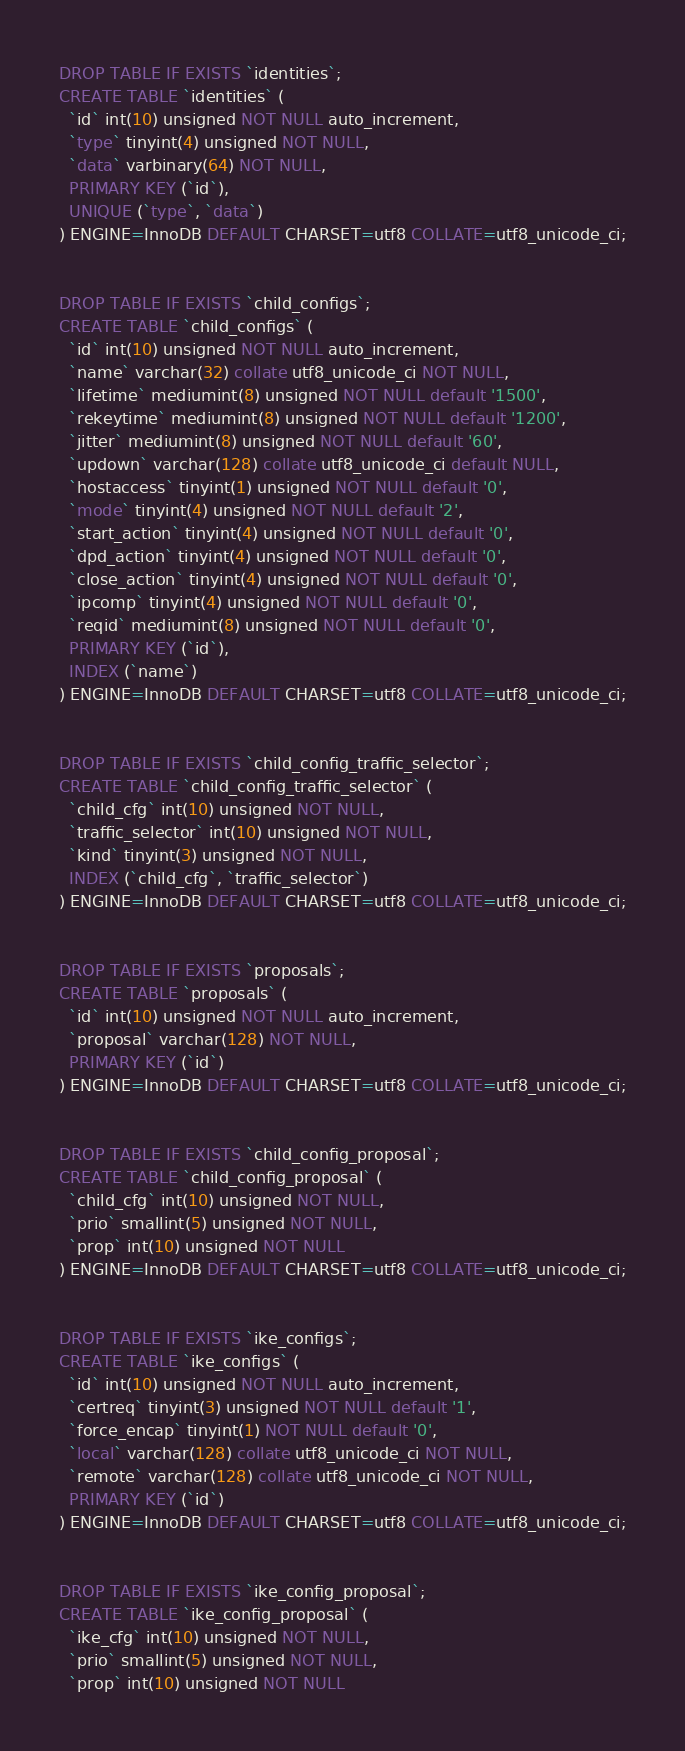<code> <loc_0><loc_0><loc_500><loc_500><_SQL_>
DROP TABLE IF EXISTS `identities`;
CREATE TABLE `identities` (
  `id` int(10) unsigned NOT NULL auto_increment,
  `type` tinyint(4) unsigned NOT NULL,
  `data` varbinary(64) NOT NULL,
  PRIMARY KEY (`id`),
  UNIQUE (`type`, `data`)
) ENGINE=InnoDB DEFAULT CHARSET=utf8 COLLATE=utf8_unicode_ci;


DROP TABLE IF EXISTS `child_configs`;
CREATE TABLE `child_configs` (
  `id` int(10) unsigned NOT NULL auto_increment,
  `name` varchar(32) collate utf8_unicode_ci NOT NULL,
  `lifetime` mediumint(8) unsigned NOT NULL default '1500',
  `rekeytime` mediumint(8) unsigned NOT NULL default '1200',
  `jitter` mediumint(8) unsigned NOT NULL default '60',
  `updown` varchar(128) collate utf8_unicode_ci default NULL,
  `hostaccess` tinyint(1) unsigned NOT NULL default '0',
  `mode` tinyint(4) unsigned NOT NULL default '2',
  `start_action` tinyint(4) unsigned NOT NULL default '0',
  `dpd_action` tinyint(4) unsigned NOT NULL default '0',
  `close_action` tinyint(4) unsigned NOT NULL default '0',
  `ipcomp` tinyint(4) unsigned NOT NULL default '0',
  `reqid` mediumint(8) unsigned NOT NULL default '0',
  PRIMARY KEY (`id`),
  INDEX (`name`)
) ENGINE=InnoDB DEFAULT CHARSET=utf8 COLLATE=utf8_unicode_ci;


DROP TABLE IF EXISTS `child_config_traffic_selector`;
CREATE TABLE `child_config_traffic_selector` (
  `child_cfg` int(10) unsigned NOT NULL,
  `traffic_selector` int(10) unsigned NOT NULL,
  `kind` tinyint(3) unsigned NOT NULL,
  INDEX (`child_cfg`, `traffic_selector`)
) ENGINE=InnoDB DEFAULT CHARSET=utf8 COLLATE=utf8_unicode_ci;


DROP TABLE IF EXISTS `proposals`;
CREATE TABLE `proposals` (
  `id` int(10) unsigned NOT NULL auto_increment,
  `proposal` varchar(128) NOT NULL,
  PRIMARY KEY (`id`)
) ENGINE=InnoDB DEFAULT CHARSET=utf8 COLLATE=utf8_unicode_ci;


DROP TABLE IF EXISTS `child_config_proposal`;
CREATE TABLE `child_config_proposal` (
  `child_cfg` int(10) unsigned NOT NULL,
  `prio` smallint(5) unsigned NOT NULL,
  `prop` int(10) unsigned NOT NULL
) ENGINE=InnoDB DEFAULT CHARSET=utf8 COLLATE=utf8_unicode_ci;


DROP TABLE IF EXISTS `ike_configs`;
CREATE TABLE `ike_configs` (
  `id` int(10) unsigned NOT NULL auto_increment,
  `certreq` tinyint(3) unsigned NOT NULL default '1',
  `force_encap` tinyint(1) NOT NULL default '0',
  `local` varchar(128) collate utf8_unicode_ci NOT NULL,
  `remote` varchar(128) collate utf8_unicode_ci NOT NULL,
  PRIMARY KEY (`id`)
) ENGINE=InnoDB DEFAULT CHARSET=utf8 COLLATE=utf8_unicode_ci;


DROP TABLE IF EXISTS `ike_config_proposal`;
CREATE TABLE `ike_config_proposal` (
  `ike_cfg` int(10) unsigned NOT NULL,
  `prio` smallint(5) unsigned NOT NULL,
  `prop` int(10) unsigned NOT NULL</code> 